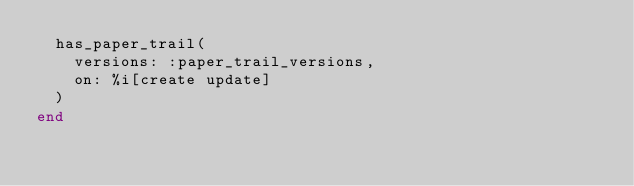<code> <loc_0><loc_0><loc_500><loc_500><_Ruby_>  has_paper_trail(
    versions: :paper_trail_versions,
    on: %i[create update]
  )
end
</code> 